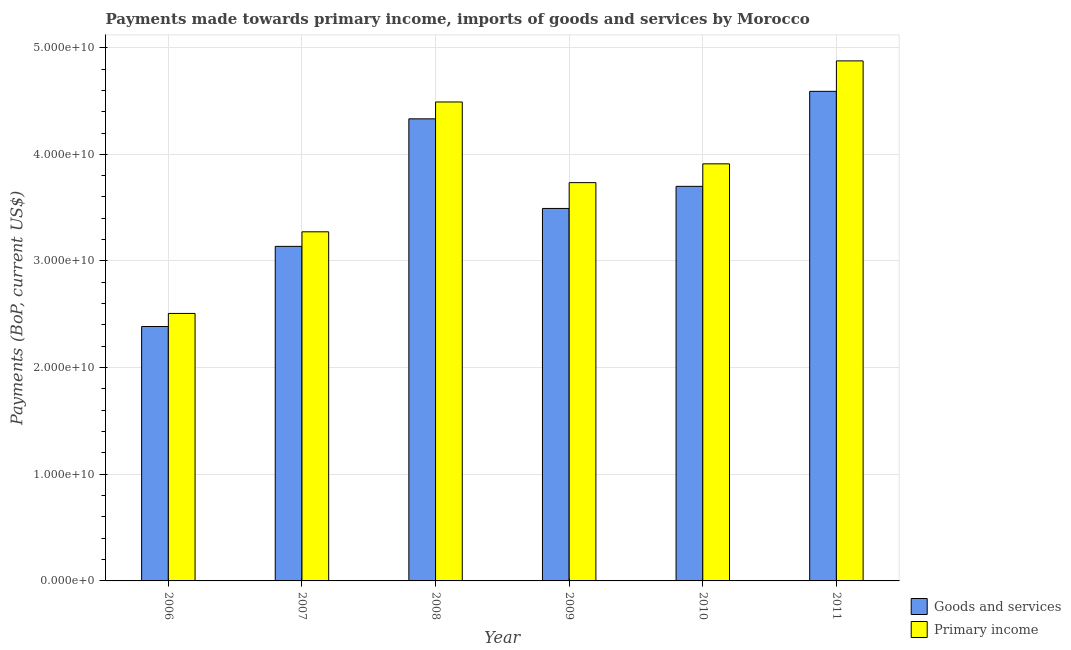How many different coloured bars are there?
Provide a succinct answer. 2. Are the number of bars on each tick of the X-axis equal?
Provide a succinct answer. Yes. How many bars are there on the 3rd tick from the left?
Your answer should be very brief. 2. What is the payments made towards primary income in 2009?
Ensure brevity in your answer.  3.73e+1. Across all years, what is the maximum payments made towards goods and services?
Your response must be concise. 4.59e+1. Across all years, what is the minimum payments made towards primary income?
Make the answer very short. 2.51e+1. In which year was the payments made towards primary income maximum?
Make the answer very short. 2011. In which year was the payments made towards primary income minimum?
Provide a short and direct response. 2006. What is the total payments made towards primary income in the graph?
Offer a very short reply. 2.28e+11. What is the difference between the payments made towards goods and services in 2008 and that in 2010?
Your answer should be compact. 6.33e+09. What is the difference between the payments made towards primary income in 2009 and the payments made towards goods and services in 2006?
Keep it short and to the point. 1.23e+1. What is the average payments made towards primary income per year?
Offer a terse response. 3.80e+1. In the year 2007, what is the difference between the payments made towards goods and services and payments made towards primary income?
Provide a succinct answer. 0. What is the ratio of the payments made towards goods and services in 2006 to that in 2007?
Provide a short and direct response. 0.76. Is the difference between the payments made towards goods and services in 2008 and 2010 greater than the difference between the payments made towards primary income in 2008 and 2010?
Ensure brevity in your answer.  No. What is the difference between the highest and the second highest payments made towards primary income?
Provide a short and direct response. 3.85e+09. What is the difference between the highest and the lowest payments made towards primary income?
Ensure brevity in your answer.  2.37e+1. Is the sum of the payments made towards primary income in 2008 and 2009 greater than the maximum payments made towards goods and services across all years?
Make the answer very short. Yes. What does the 1st bar from the left in 2008 represents?
Provide a succinct answer. Goods and services. What does the 2nd bar from the right in 2006 represents?
Give a very brief answer. Goods and services. How many bars are there?
Keep it short and to the point. 12. Are all the bars in the graph horizontal?
Provide a short and direct response. No. How many years are there in the graph?
Offer a terse response. 6. What is the difference between two consecutive major ticks on the Y-axis?
Offer a terse response. 1.00e+1. Does the graph contain grids?
Provide a succinct answer. Yes. How many legend labels are there?
Provide a succinct answer. 2. How are the legend labels stacked?
Offer a terse response. Vertical. What is the title of the graph?
Provide a short and direct response. Payments made towards primary income, imports of goods and services by Morocco. What is the label or title of the Y-axis?
Your answer should be very brief. Payments (BoP, current US$). What is the Payments (BoP, current US$) in Goods and services in 2006?
Your response must be concise. 2.39e+1. What is the Payments (BoP, current US$) of Primary income in 2006?
Give a very brief answer. 2.51e+1. What is the Payments (BoP, current US$) of Goods and services in 2007?
Offer a very short reply. 3.14e+1. What is the Payments (BoP, current US$) of Primary income in 2007?
Offer a very short reply. 3.27e+1. What is the Payments (BoP, current US$) in Goods and services in 2008?
Offer a terse response. 4.33e+1. What is the Payments (BoP, current US$) of Primary income in 2008?
Offer a very short reply. 4.49e+1. What is the Payments (BoP, current US$) in Goods and services in 2009?
Keep it short and to the point. 3.49e+1. What is the Payments (BoP, current US$) of Primary income in 2009?
Your answer should be compact. 3.73e+1. What is the Payments (BoP, current US$) of Goods and services in 2010?
Offer a terse response. 3.70e+1. What is the Payments (BoP, current US$) in Primary income in 2010?
Your answer should be very brief. 3.91e+1. What is the Payments (BoP, current US$) of Goods and services in 2011?
Keep it short and to the point. 4.59e+1. What is the Payments (BoP, current US$) of Primary income in 2011?
Keep it short and to the point. 4.88e+1. Across all years, what is the maximum Payments (BoP, current US$) of Goods and services?
Keep it short and to the point. 4.59e+1. Across all years, what is the maximum Payments (BoP, current US$) of Primary income?
Give a very brief answer. 4.88e+1. Across all years, what is the minimum Payments (BoP, current US$) in Goods and services?
Make the answer very short. 2.39e+1. Across all years, what is the minimum Payments (BoP, current US$) of Primary income?
Offer a terse response. 2.51e+1. What is the total Payments (BoP, current US$) of Goods and services in the graph?
Give a very brief answer. 2.16e+11. What is the total Payments (BoP, current US$) of Primary income in the graph?
Your response must be concise. 2.28e+11. What is the difference between the Payments (BoP, current US$) in Goods and services in 2006 and that in 2007?
Provide a succinct answer. -7.51e+09. What is the difference between the Payments (BoP, current US$) in Primary income in 2006 and that in 2007?
Your response must be concise. -7.65e+09. What is the difference between the Payments (BoP, current US$) of Goods and services in 2006 and that in 2008?
Provide a succinct answer. -1.95e+1. What is the difference between the Payments (BoP, current US$) in Primary income in 2006 and that in 2008?
Ensure brevity in your answer.  -1.98e+1. What is the difference between the Payments (BoP, current US$) of Goods and services in 2006 and that in 2009?
Your answer should be compact. -1.11e+1. What is the difference between the Payments (BoP, current US$) in Primary income in 2006 and that in 2009?
Provide a succinct answer. -1.23e+1. What is the difference between the Payments (BoP, current US$) of Goods and services in 2006 and that in 2010?
Provide a succinct answer. -1.31e+1. What is the difference between the Payments (BoP, current US$) of Primary income in 2006 and that in 2010?
Your answer should be very brief. -1.40e+1. What is the difference between the Payments (BoP, current US$) of Goods and services in 2006 and that in 2011?
Provide a succinct answer. -2.21e+1. What is the difference between the Payments (BoP, current US$) in Primary income in 2006 and that in 2011?
Keep it short and to the point. -2.37e+1. What is the difference between the Payments (BoP, current US$) in Goods and services in 2007 and that in 2008?
Your answer should be very brief. -1.20e+1. What is the difference between the Payments (BoP, current US$) of Primary income in 2007 and that in 2008?
Offer a very short reply. -1.22e+1. What is the difference between the Payments (BoP, current US$) in Goods and services in 2007 and that in 2009?
Provide a short and direct response. -3.56e+09. What is the difference between the Payments (BoP, current US$) of Primary income in 2007 and that in 2009?
Provide a succinct answer. -4.61e+09. What is the difference between the Payments (BoP, current US$) of Goods and services in 2007 and that in 2010?
Ensure brevity in your answer.  -5.63e+09. What is the difference between the Payments (BoP, current US$) in Primary income in 2007 and that in 2010?
Provide a succinct answer. -6.37e+09. What is the difference between the Payments (BoP, current US$) of Goods and services in 2007 and that in 2011?
Ensure brevity in your answer.  -1.45e+1. What is the difference between the Payments (BoP, current US$) of Primary income in 2007 and that in 2011?
Give a very brief answer. -1.60e+1. What is the difference between the Payments (BoP, current US$) of Goods and services in 2008 and that in 2009?
Make the answer very short. 8.40e+09. What is the difference between the Payments (BoP, current US$) in Primary income in 2008 and that in 2009?
Your answer should be compact. 7.56e+09. What is the difference between the Payments (BoP, current US$) in Goods and services in 2008 and that in 2010?
Give a very brief answer. 6.33e+09. What is the difference between the Payments (BoP, current US$) in Primary income in 2008 and that in 2010?
Provide a succinct answer. 5.80e+09. What is the difference between the Payments (BoP, current US$) in Goods and services in 2008 and that in 2011?
Keep it short and to the point. -2.58e+09. What is the difference between the Payments (BoP, current US$) of Primary income in 2008 and that in 2011?
Keep it short and to the point. -3.85e+09. What is the difference between the Payments (BoP, current US$) of Goods and services in 2009 and that in 2010?
Offer a very short reply. -2.07e+09. What is the difference between the Payments (BoP, current US$) of Primary income in 2009 and that in 2010?
Ensure brevity in your answer.  -1.76e+09. What is the difference between the Payments (BoP, current US$) of Goods and services in 2009 and that in 2011?
Give a very brief answer. -1.10e+1. What is the difference between the Payments (BoP, current US$) in Primary income in 2009 and that in 2011?
Keep it short and to the point. -1.14e+1. What is the difference between the Payments (BoP, current US$) of Goods and services in 2010 and that in 2011?
Make the answer very short. -8.91e+09. What is the difference between the Payments (BoP, current US$) of Primary income in 2010 and that in 2011?
Provide a succinct answer. -9.65e+09. What is the difference between the Payments (BoP, current US$) of Goods and services in 2006 and the Payments (BoP, current US$) of Primary income in 2007?
Your answer should be very brief. -8.88e+09. What is the difference between the Payments (BoP, current US$) of Goods and services in 2006 and the Payments (BoP, current US$) of Primary income in 2008?
Ensure brevity in your answer.  -2.11e+1. What is the difference between the Payments (BoP, current US$) in Goods and services in 2006 and the Payments (BoP, current US$) in Primary income in 2009?
Your answer should be very brief. -1.35e+1. What is the difference between the Payments (BoP, current US$) of Goods and services in 2006 and the Payments (BoP, current US$) of Primary income in 2010?
Keep it short and to the point. -1.53e+1. What is the difference between the Payments (BoP, current US$) of Goods and services in 2006 and the Payments (BoP, current US$) of Primary income in 2011?
Ensure brevity in your answer.  -2.49e+1. What is the difference between the Payments (BoP, current US$) in Goods and services in 2007 and the Payments (BoP, current US$) in Primary income in 2008?
Make the answer very short. -1.35e+1. What is the difference between the Payments (BoP, current US$) in Goods and services in 2007 and the Payments (BoP, current US$) in Primary income in 2009?
Your answer should be compact. -5.98e+09. What is the difference between the Payments (BoP, current US$) in Goods and services in 2007 and the Payments (BoP, current US$) in Primary income in 2010?
Keep it short and to the point. -7.74e+09. What is the difference between the Payments (BoP, current US$) in Goods and services in 2007 and the Payments (BoP, current US$) in Primary income in 2011?
Provide a short and direct response. -1.74e+1. What is the difference between the Payments (BoP, current US$) of Goods and services in 2008 and the Payments (BoP, current US$) of Primary income in 2009?
Your response must be concise. 5.98e+09. What is the difference between the Payments (BoP, current US$) in Goods and services in 2008 and the Payments (BoP, current US$) in Primary income in 2010?
Offer a terse response. 4.22e+09. What is the difference between the Payments (BoP, current US$) in Goods and services in 2008 and the Payments (BoP, current US$) in Primary income in 2011?
Provide a short and direct response. -5.43e+09. What is the difference between the Payments (BoP, current US$) in Goods and services in 2009 and the Payments (BoP, current US$) in Primary income in 2010?
Your answer should be compact. -4.18e+09. What is the difference between the Payments (BoP, current US$) in Goods and services in 2009 and the Payments (BoP, current US$) in Primary income in 2011?
Give a very brief answer. -1.38e+1. What is the difference between the Payments (BoP, current US$) of Goods and services in 2010 and the Payments (BoP, current US$) of Primary income in 2011?
Make the answer very short. -1.18e+1. What is the average Payments (BoP, current US$) in Goods and services per year?
Give a very brief answer. 3.61e+1. What is the average Payments (BoP, current US$) in Primary income per year?
Your answer should be very brief. 3.80e+1. In the year 2006, what is the difference between the Payments (BoP, current US$) in Goods and services and Payments (BoP, current US$) in Primary income?
Your answer should be compact. -1.23e+09. In the year 2007, what is the difference between the Payments (BoP, current US$) in Goods and services and Payments (BoP, current US$) in Primary income?
Provide a short and direct response. -1.37e+09. In the year 2008, what is the difference between the Payments (BoP, current US$) of Goods and services and Payments (BoP, current US$) of Primary income?
Give a very brief answer. -1.58e+09. In the year 2009, what is the difference between the Payments (BoP, current US$) of Goods and services and Payments (BoP, current US$) of Primary income?
Your answer should be compact. -2.42e+09. In the year 2010, what is the difference between the Payments (BoP, current US$) in Goods and services and Payments (BoP, current US$) in Primary income?
Keep it short and to the point. -2.11e+09. In the year 2011, what is the difference between the Payments (BoP, current US$) of Goods and services and Payments (BoP, current US$) of Primary income?
Offer a terse response. -2.86e+09. What is the ratio of the Payments (BoP, current US$) of Goods and services in 2006 to that in 2007?
Give a very brief answer. 0.76. What is the ratio of the Payments (BoP, current US$) in Primary income in 2006 to that in 2007?
Offer a very short reply. 0.77. What is the ratio of the Payments (BoP, current US$) of Goods and services in 2006 to that in 2008?
Your answer should be compact. 0.55. What is the ratio of the Payments (BoP, current US$) of Primary income in 2006 to that in 2008?
Offer a very short reply. 0.56. What is the ratio of the Payments (BoP, current US$) of Goods and services in 2006 to that in 2009?
Give a very brief answer. 0.68. What is the ratio of the Payments (BoP, current US$) of Primary income in 2006 to that in 2009?
Provide a short and direct response. 0.67. What is the ratio of the Payments (BoP, current US$) in Goods and services in 2006 to that in 2010?
Your response must be concise. 0.64. What is the ratio of the Payments (BoP, current US$) of Primary income in 2006 to that in 2010?
Ensure brevity in your answer.  0.64. What is the ratio of the Payments (BoP, current US$) of Goods and services in 2006 to that in 2011?
Give a very brief answer. 0.52. What is the ratio of the Payments (BoP, current US$) in Primary income in 2006 to that in 2011?
Offer a terse response. 0.51. What is the ratio of the Payments (BoP, current US$) of Goods and services in 2007 to that in 2008?
Offer a terse response. 0.72. What is the ratio of the Payments (BoP, current US$) of Primary income in 2007 to that in 2008?
Keep it short and to the point. 0.73. What is the ratio of the Payments (BoP, current US$) in Goods and services in 2007 to that in 2009?
Offer a terse response. 0.9. What is the ratio of the Payments (BoP, current US$) of Primary income in 2007 to that in 2009?
Ensure brevity in your answer.  0.88. What is the ratio of the Payments (BoP, current US$) of Goods and services in 2007 to that in 2010?
Offer a terse response. 0.85. What is the ratio of the Payments (BoP, current US$) of Primary income in 2007 to that in 2010?
Make the answer very short. 0.84. What is the ratio of the Payments (BoP, current US$) of Goods and services in 2007 to that in 2011?
Offer a very short reply. 0.68. What is the ratio of the Payments (BoP, current US$) in Primary income in 2007 to that in 2011?
Keep it short and to the point. 0.67. What is the ratio of the Payments (BoP, current US$) of Goods and services in 2008 to that in 2009?
Offer a very short reply. 1.24. What is the ratio of the Payments (BoP, current US$) in Primary income in 2008 to that in 2009?
Ensure brevity in your answer.  1.2. What is the ratio of the Payments (BoP, current US$) in Goods and services in 2008 to that in 2010?
Give a very brief answer. 1.17. What is the ratio of the Payments (BoP, current US$) in Primary income in 2008 to that in 2010?
Your answer should be compact. 1.15. What is the ratio of the Payments (BoP, current US$) of Goods and services in 2008 to that in 2011?
Keep it short and to the point. 0.94. What is the ratio of the Payments (BoP, current US$) in Primary income in 2008 to that in 2011?
Ensure brevity in your answer.  0.92. What is the ratio of the Payments (BoP, current US$) of Goods and services in 2009 to that in 2010?
Provide a short and direct response. 0.94. What is the ratio of the Payments (BoP, current US$) in Primary income in 2009 to that in 2010?
Ensure brevity in your answer.  0.95. What is the ratio of the Payments (BoP, current US$) in Goods and services in 2009 to that in 2011?
Offer a terse response. 0.76. What is the ratio of the Payments (BoP, current US$) of Primary income in 2009 to that in 2011?
Your answer should be very brief. 0.77. What is the ratio of the Payments (BoP, current US$) of Goods and services in 2010 to that in 2011?
Give a very brief answer. 0.81. What is the ratio of the Payments (BoP, current US$) of Primary income in 2010 to that in 2011?
Offer a very short reply. 0.8. What is the difference between the highest and the second highest Payments (BoP, current US$) of Goods and services?
Your answer should be compact. 2.58e+09. What is the difference between the highest and the second highest Payments (BoP, current US$) in Primary income?
Provide a short and direct response. 3.85e+09. What is the difference between the highest and the lowest Payments (BoP, current US$) of Goods and services?
Offer a terse response. 2.21e+1. What is the difference between the highest and the lowest Payments (BoP, current US$) of Primary income?
Make the answer very short. 2.37e+1. 